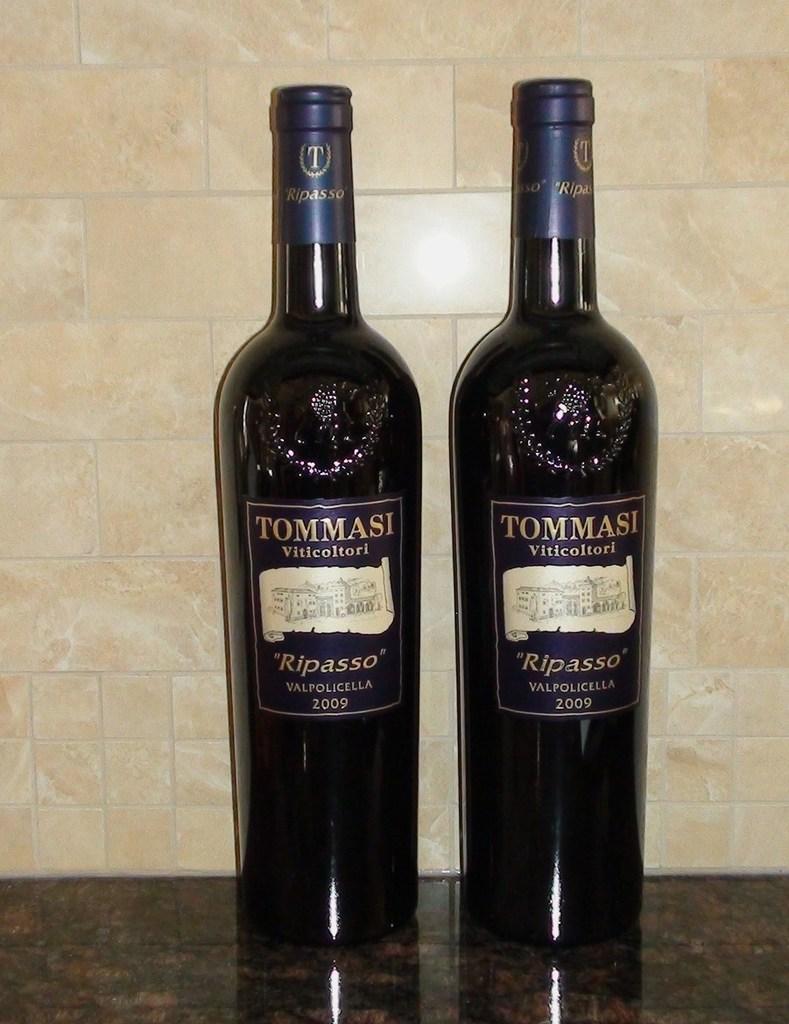What brand is advertised on this boat?
Keep it short and to the point. Unanswerable. What year is on the bottle?
Make the answer very short. 2009. 